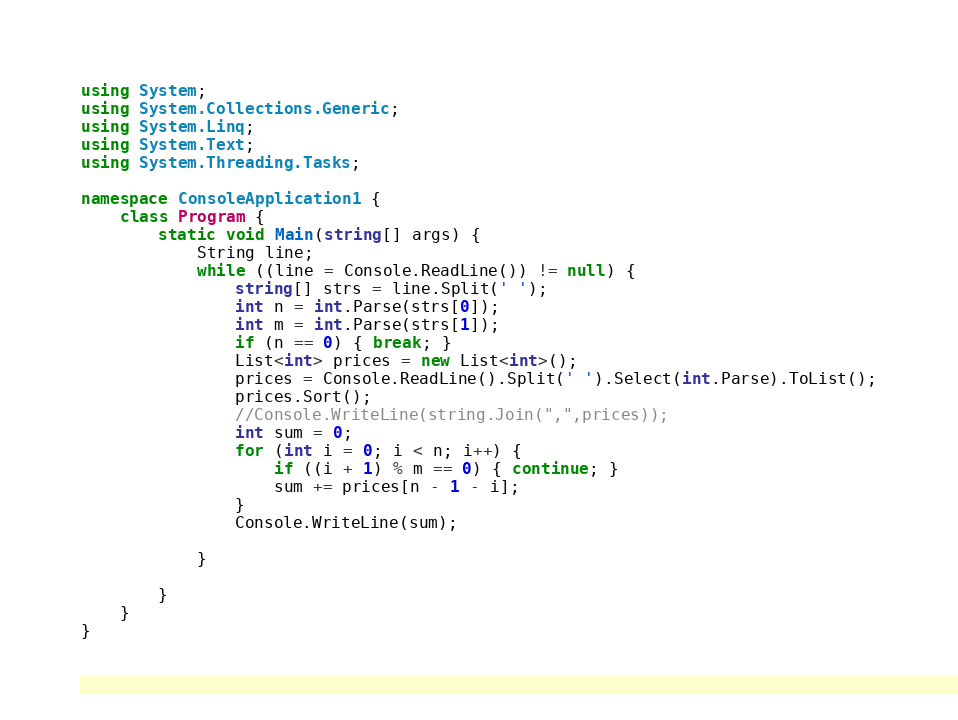Convert code to text. <code><loc_0><loc_0><loc_500><loc_500><_C#_>using System;
using System.Collections.Generic;
using System.Linq;
using System.Text;
using System.Threading.Tasks;

namespace ConsoleApplication1 {
    class Program {
        static void Main(string[] args) {
            String line;
            while ((line = Console.ReadLine()) != null) {
                string[] strs = line.Split(' ');
                int n = int.Parse(strs[0]);
                int m = int.Parse(strs[1]);
                if (n == 0) { break; }
                List<int> prices = new List<int>();
                prices = Console.ReadLine().Split(' ').Select(int.Parse).ToList();
                prices.Sort();
                //Console.WriteLine(string.Join(",",prices));
                int sum = 0;
                for (int i = 0; i < n; i++) {
                    if ((i + 1) % m == 0) { continue; }
                    sum += prices[n - 1 - i];
                }
                Console.WriteLine(sum);

            }

        }
    }
}</code> 